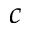<formula> <loc_0><loc_0><loc_500><loc_500>c</formula> 